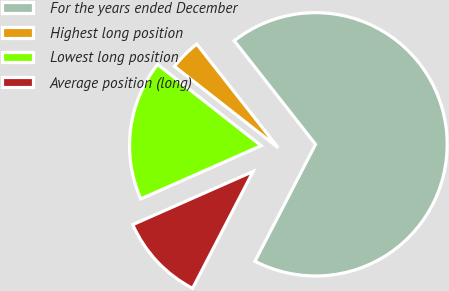Convert chart. <chart><loc_0><loc_0><loc_500><loc_500><pie_chart><fcel>For the years ended December<fcel>Highest long position<fcel>Lowest long position<fcel>Average position (long)<nl><fcel>68.2%<fcel>3.82%<fcel>17.21%<fcel>10.77%<nl></chart> 